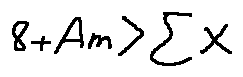Convert formula to latex. <formula><loc_0><loc_0><loc_500><loc_500>8 + A m > \sum X</formula> 